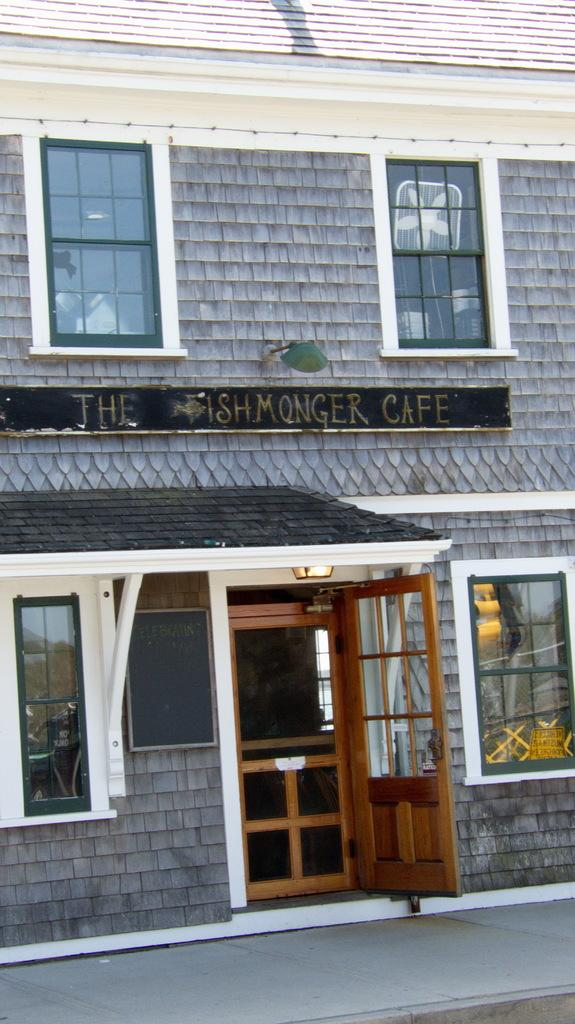What type of door is visible in the image? There is a wooden door in the image. What other architectural features can be seen in the image? There are glass windows in the image. What type of structure is depicted in the image? There is a house in the image. Can you describe any additional features of the house? There is a light arrangement on the roof of the house. How does the beginner learn to jump in the image? There is no reference to a beginner or jumping in the image; it features a wooden door, glass windows, a house, and a light arrangement on the roof. 